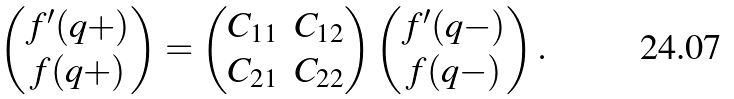<formula> <loc_0><loc_0><loc_500><loc_500>\begin{pmatrix} f ^ { \prime } ( q + ) \\ f ( q + ) \end{pmatrix} = \begin{pmatrix} C _ { 1 1 } & C _ { 1 2 } \\ C _ { 2 1 } & C _ { 2 2 } \end{pmatrix} \begin{pmatrix} f ^ { \prime } ( q - ) \\ f ( q - ) \end{pmatrix} .</formula> 